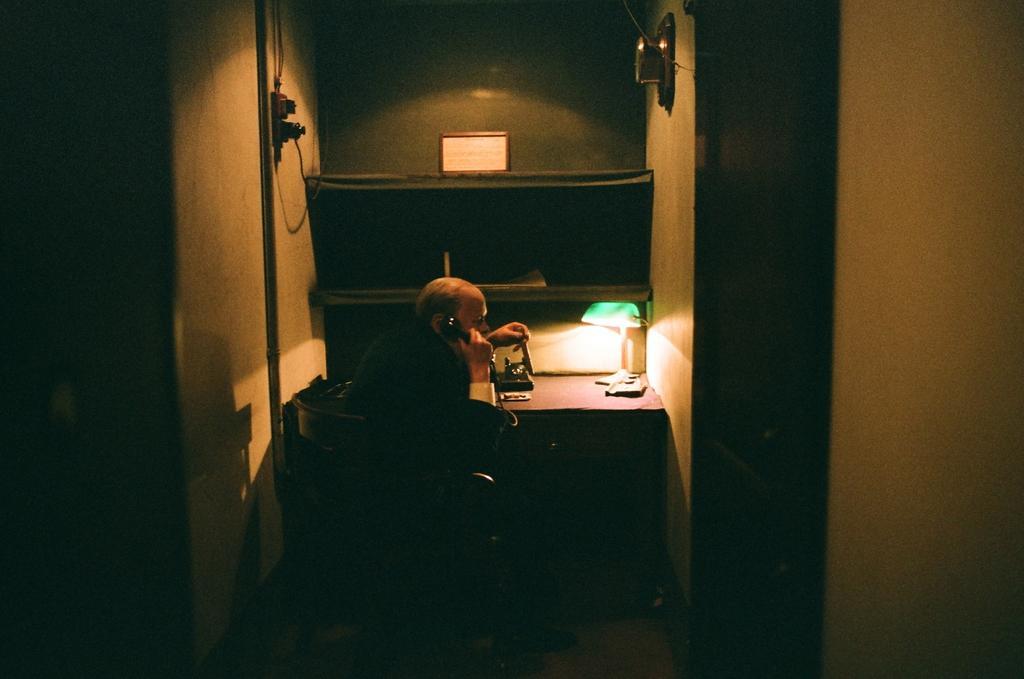Can you describe this image briefly? This is the man sitting on the chair and holding a telephone handset. Here is the table with a lamp, telephone and few other things on it. This looks like a frame. I think this is a rack. This looks like a socket, which is attached to the wall. This looks like a door. 